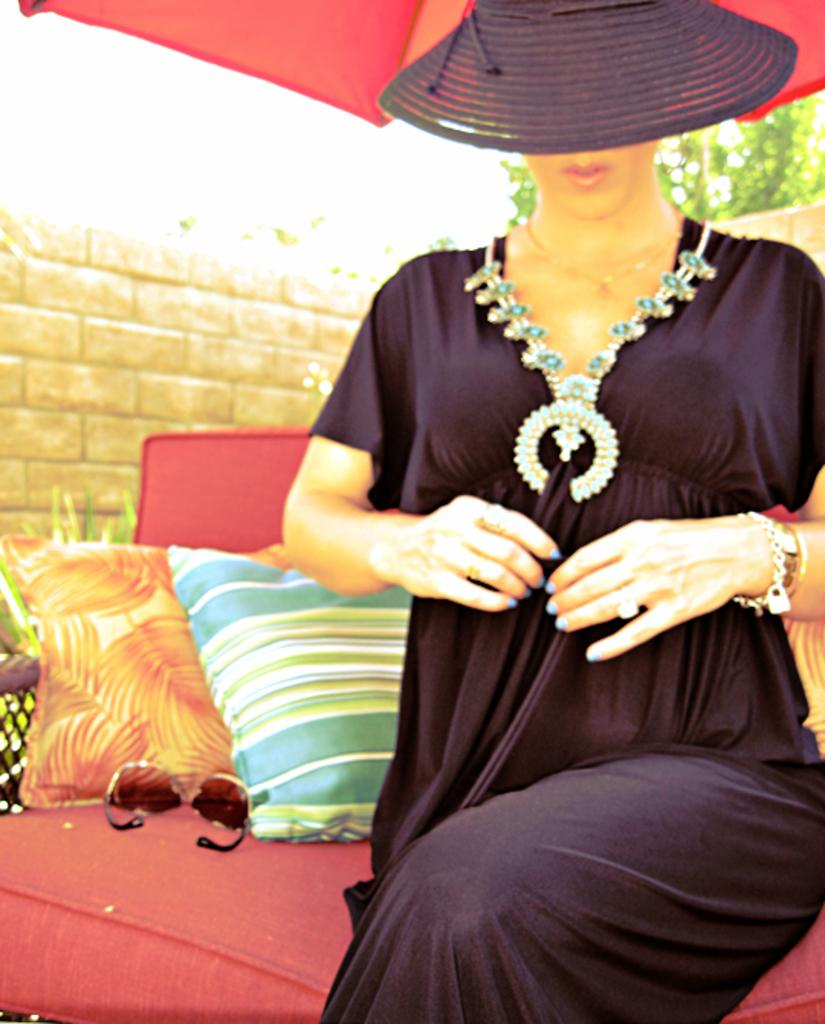What is the lady in the image doing? The lady is sitting on the couch in the image. What is the lady wearing on her head? The lady is wearing a hat in the image. What can be seen on the couch besides the lady? There are cushions and sunglasses on the couch in the image. What is visible behind the lady? There is a wall visible in the image. What type of vegetation is present in the image? There is a plant in the image. What type of cake is being served on the couch? There is no cake present in the image; it features a lady sitting on the couch with a hat, cushions, sunglasses, a wall, and a plant. 